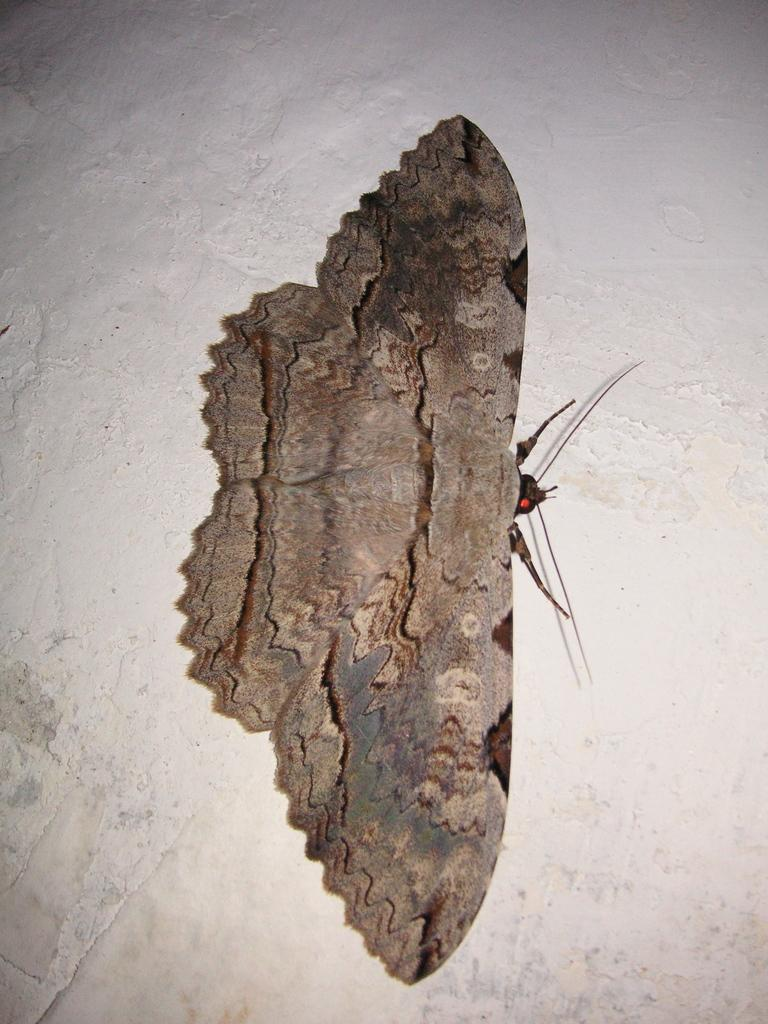What type of creature is in the picture? There is an insect in the picture. What features does the insect have? The insect has wings, legs, a head, and a body. What can be seen in the background of the picture? There is a wall in the background of the picture. Can you tell me how many bubbles are surrounding the insect in the image? There are no bubbles present in the image; it features an insect with wings, legs, a head, and a body, along with a wall in the background. 